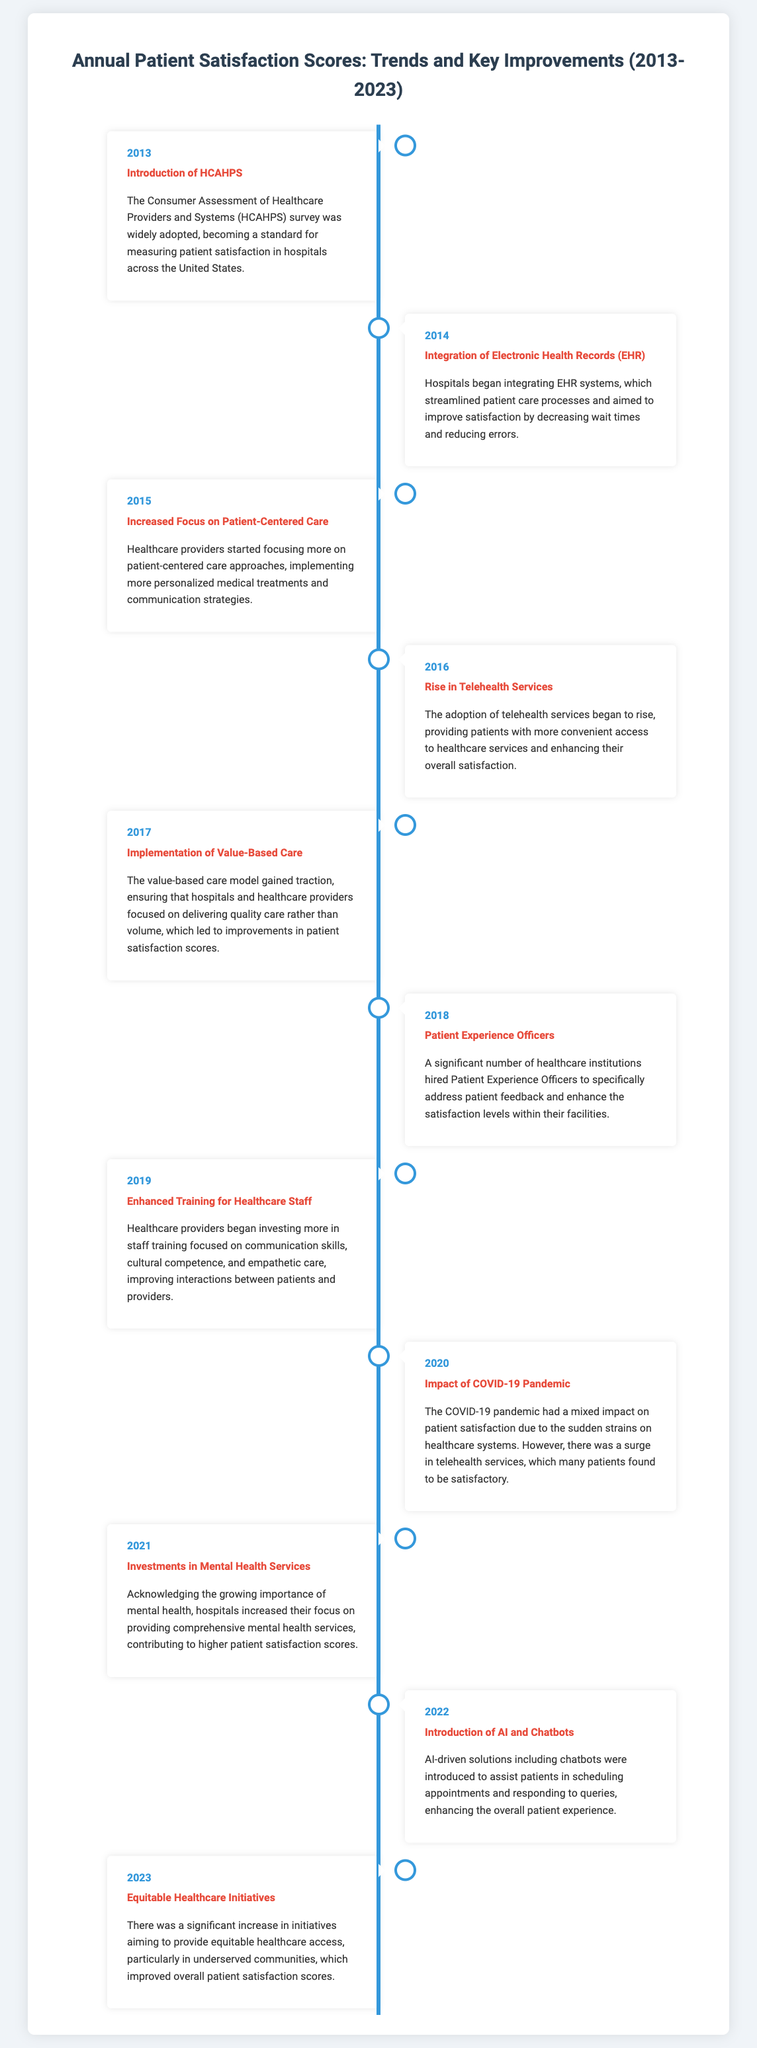What year was the HCAHPS survey introduced? The document states that the HCAHPS survey was introduced in 2013.
Answer: 2013 What improvement was made in 2018 regarding patient experience? The document highlights that many healthcare institutions hired Patient Experience Officers in 2018.
Answer: Patient Experience Officers Which year saw the implementation of value-based care? The timeline indicates that the value-based care model was implemented in 2017.
Answer: 2017 What type of services increased and contributed to patient satisfaction in 2020? The document notes that telehealth services surged during the COVID-19 pandemic in 2020.
Answer: Telehealth services In what year did hospitals begin to invest in mental health services? According to the timeline, hospitals increased investments in mental health services in 2021.
Answer: 2021 Which technology was introduced in 2022 to assist patients? The document states that AI and chatbots were introduced to assist patients in 2022.
Answer: AI and chatbots What was a significant theme in patient satisfaction improvements from 2013 to 2023? The timeline shows a consistent focus on enhancing patient access and care quality over the years.
Answer: Patient access and care quality What year had a mixed impact due to the COVID-19 pandemic? The document mentions that 2020 had a mixed impact on patient satisfaction due to the COVID-19 pandemic.
Answer: 2020 How many years does the timeline cover? The timeline indicates that it covers the years from 2013 to 2023, which is 11 years in total.
Answer: 11 years 